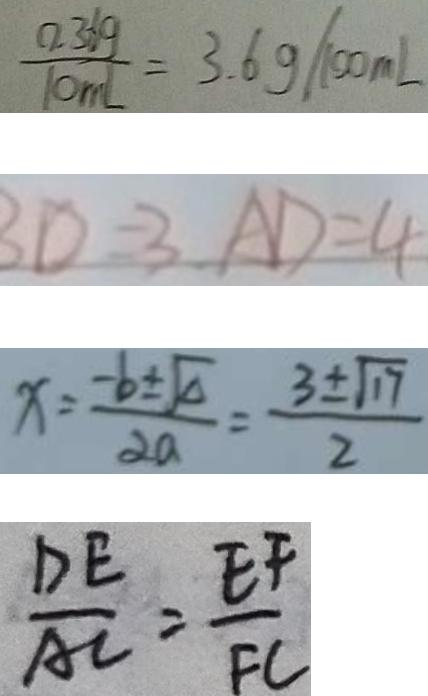Convert formula to latex. <formula><loc_0><loc_0><loc_500><loc_500>\frac { 0 . 3 6 g } { 1 0 m l } = 3 . 6 g / 1 0 0 m L 
 B D = 3 A D = 4 
 x = \frac { - b \pm \sqrt { \Delta } } { 2 a } = \frac { 3 \pm \sqrt { 1 7 } } { 2 } 
 \frac { D E } { A C } = \frac { E F } { F C }</formula> 